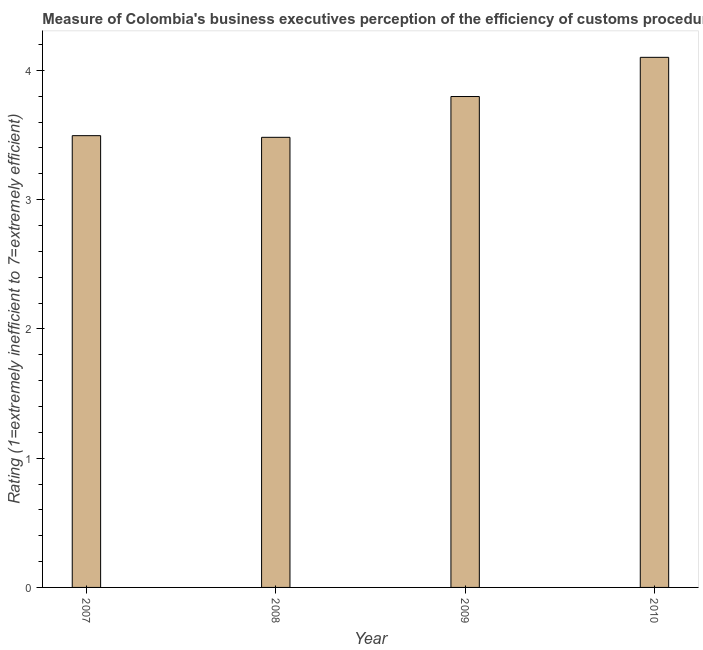Does the graph contain any zero values?
Your response must be concise. No. What is the title of the graph?
Your response must be concise. Measure of Colombia's business executives perception of the efficiency of customs procedures. What is the label or title of the Y-axis?
Your answer should be very brief. Rating (1=extremely inefficient to 7=extremely efficient). What is the rating measuring burden of customs procedure in 2007?
Provide a succinct answer. 3.49. Across all years, what is the maximum rating measuring burden of customs procedure?
Offer a terse response. 4.1. Across all years, what is the minimum rating measuring burden of customs procedure?
Provide a short and direct response. 3.48. In which year was the rating measuring burden of customs procedure maximum?
Provide a short and direct response. 2010. In which year was the rating measuring burden of customs procedure minimum?
Your answer should be very brief. 2008. What is the sum of the rating measuring burden of customs procedure?
Keep it short and to the point. 14.87. What is the difference between the rating measuring burden of customs procedure in 2008 and 2009?
Your answer should be very brief. -0.32. What is the average rating measuring burden of customs procedure per year?
Ensure brevity in your answer.  3.72. What is the median rating measuring burden of customs procedure?
Keep it short and to the point. 3.65. Do a majority of the years between 2009 and 2007 (inclusive) have rating measuring burden of customs procedure greater than 3.8 ?
Provide a short and direct response. Yes. What is the ratio of the rating measuring burden of customs procedure in 2009 to that in 2010?
Make the answer very short. 0.93. Is the rating measuring burden of customs procedure in 2007 less than that in 2010?
Your answer should be very brief. Yes. Is the difference between the rating measuring burden of customs procedure in 2008 and 2009 greater than the difference between any two years?
Offer a very short reply. No. What is the difference between the highest and the second highest rating measuring burden of customs procedure?
Give a very brief answer. 0.3. Is the sum of the rating measuring burden of customs procedure in 2007 and 2009 greater than the maximum rating measuring burden of customs procedure across all years?
Keep it short and to the point. Yes. What is the difference between the highest and the lowest rating measuring burden of customs procedure?
Offer a very short reply. 0.62. In how many years, is the rating measuring burden of customs procedure greater than the average rating measuring burden of customs procedure taken over all years?
Your response must be concise. 2. Are the values on the major ticks of Y-axis written in scientific E-notation?
Provide a succinct answer. No. What is the Rating (1=extremely inefficient to 7=extremely efficient) in 2007?
Keep it short and to the point. 3.49. What is the Rating (1=extremely inefficient to 7=extremely efficient) in 2008?
Offer a terse response. 3.48. What is the Rating (1=extremely inefficient to 7=extremely efficient) of 2009?
Ensure brevity in your answer.  3.8. What is the Rating (1=extremely inefficient to 7=extremely efficient) of 2010?
Make the answer very short. 4.1. What is the difference between the Rating (1=extremely inefficient to 7=extremely efficient) in 2007 and 2008?
Keep it short and to the point. 0.01. What is the difference between the Rating (1=extremely inefficient to 7=extremely efficient) in 2007 and 2009?
Your answer should be very brief. -0.3. What is the difference between the Rating (1=extremely inefficient to 7=extremely efficient) in 2007 and 2010?
Your answer should be very brief. -0.61. What is the difference between the Rating (1=extremely inefficient to 7=extremely efficient) in 2008 and 2009?
Your response must be concise. -0.32. What is the difference between the Rating (1=extremely inefficient to 7=extremely efficient) in 2008 and 2010?
Keep it short and to the point. -0.62. What is the difference between the Rating (1=extremely inefficient to 7=extremely efficient) in 2009 and 2010?
Offer a very short reply. -0.3. What is the ratio of the Rating (1=extremely inefficient to 7=extremely efficient) in 2007 to that in 2010?
Offer a very short reply. 0.85. What is the ratio of the Rating (1=extremely inefficient to 7=extremely efficient) in 2008 to that in 2009?
Make the answer very short. 0.92. What is the ratio of the Rating (1=extremely inefficient to 7=extremely efficient) in 2008 to that in 2010?
Offer a very short reply. 0.85. What is the ratio of the Rating (1=extremely inefficient to 7=extremely efficient) in 2009 to that in 2010?
Offer a terse response. 0.93. 